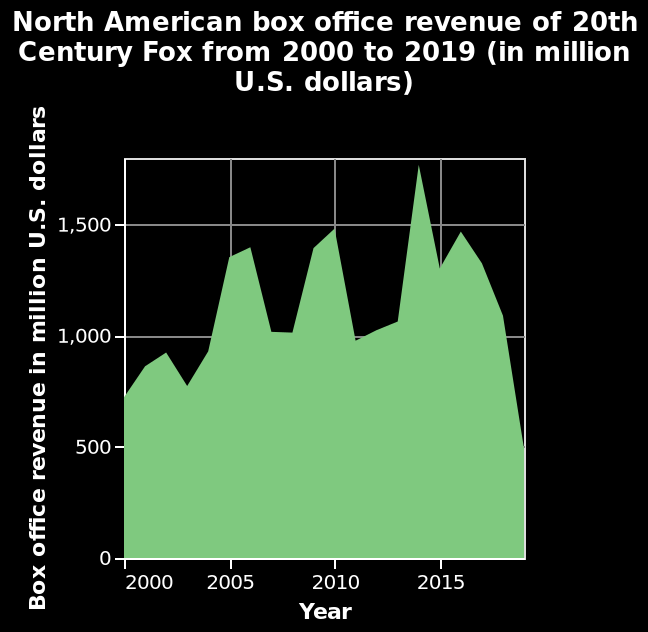<image>
Describe the following image in detail This area diagram is labeled North American box office revenue of 20th Century Fox from 2000 to 2019 (in million U.S. dollars). Box office revenue in million U.S. dollars is plotted on the y-axis. Along the x-axis, Year is drawn using a linear scale with a minimum of 2000 and a maximum of 2015. How much revenue did 20th Century Fox earn at its peak in 2014? Nearly 1,700 million dollars. Why did 20th Century Fox's revenue decline from 2016 to 2020? It suffered a huge loss during that period. When did 20th Century Fox experience its lowest revenue? In the year 2020. 